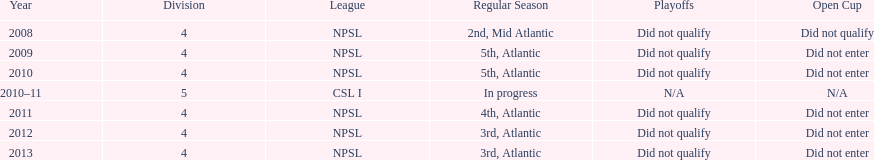What was the last year they were 5th? 2010. 